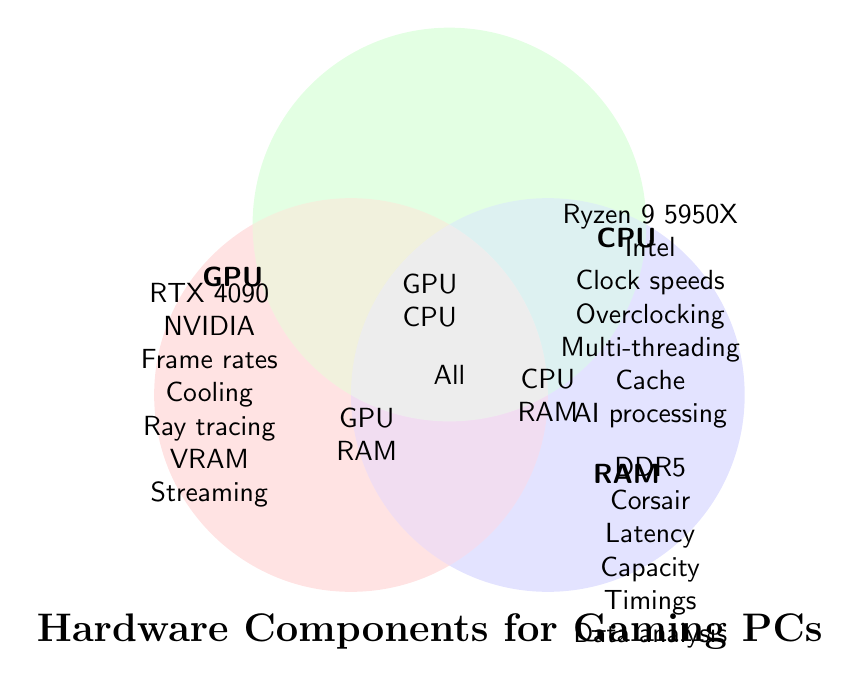What are the three main hardware categories shown in the diagram? The titles of each category are placed near each circle in the Venn diagram, labeled as GPU, CPU, and RAM.
Answer: GPU, CPU, RAM Which brand belongs to all three hardware categories? The brand names are listed inside the circles for each category. The brand "Corsair" is mentioned exclusively under RAM, but no brand is listed for all three categories.
Answer: None Identify a feature unique to GPUs. Features listed inside the GPU circle include items not found in the CPU or RAM circles. Ray tracing is one of those features.
Answer: Ray tracing What common feature is shared between GPUs and CPUs but not RAM? Inside the overlapping region between GPU and CPU (but outside RAM), we find shared features. These include Cooling and Overclocking.
Answer: Cooling, Overclocking Which intersection covers all three hardware components? The central overlapping region between all three circles (GPU, CPU, RAM) has a single label "All."
Answer: All Among GPU, CPU, and RAM, which category specifically mentions latency? Latency is listed within the text under the RAM circle.
Answer: RAM List a feature both CPUs and RAM share, but not GPUs. Features listed in the overlap area between CPUs and RAM without overlap with GPUs include Capacity and Timings.
Answer: Capacity, Timings What high-performance CPU model is highlighted for gaming? The model named for CPU is Ryzen 9 5950X, as found within the CPU circle.
Answer: Ryzen 9 5950X Which component is crucial for VRAM in gaming PCs? VRAM is identified inside the GPU circle, indicating it is a feature of the GPU.
Answer: GPU 